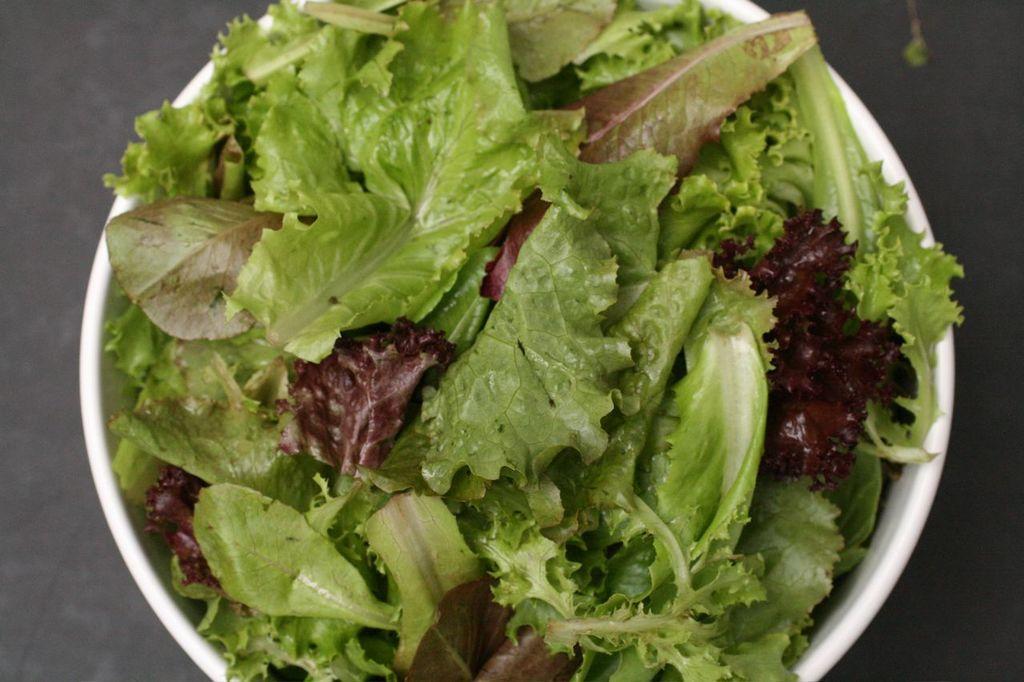How would you summarize this image in a sentence or two? There are leaves in a white color bowl. Which is on the floor. And the background is gray in color. 